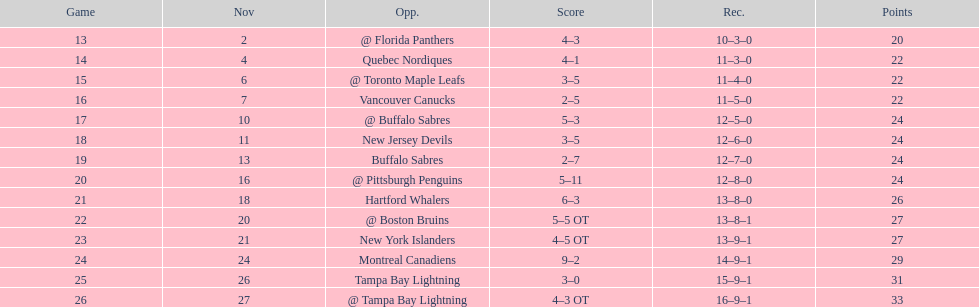Were the new jersey devils in last place according to the chart? No. 